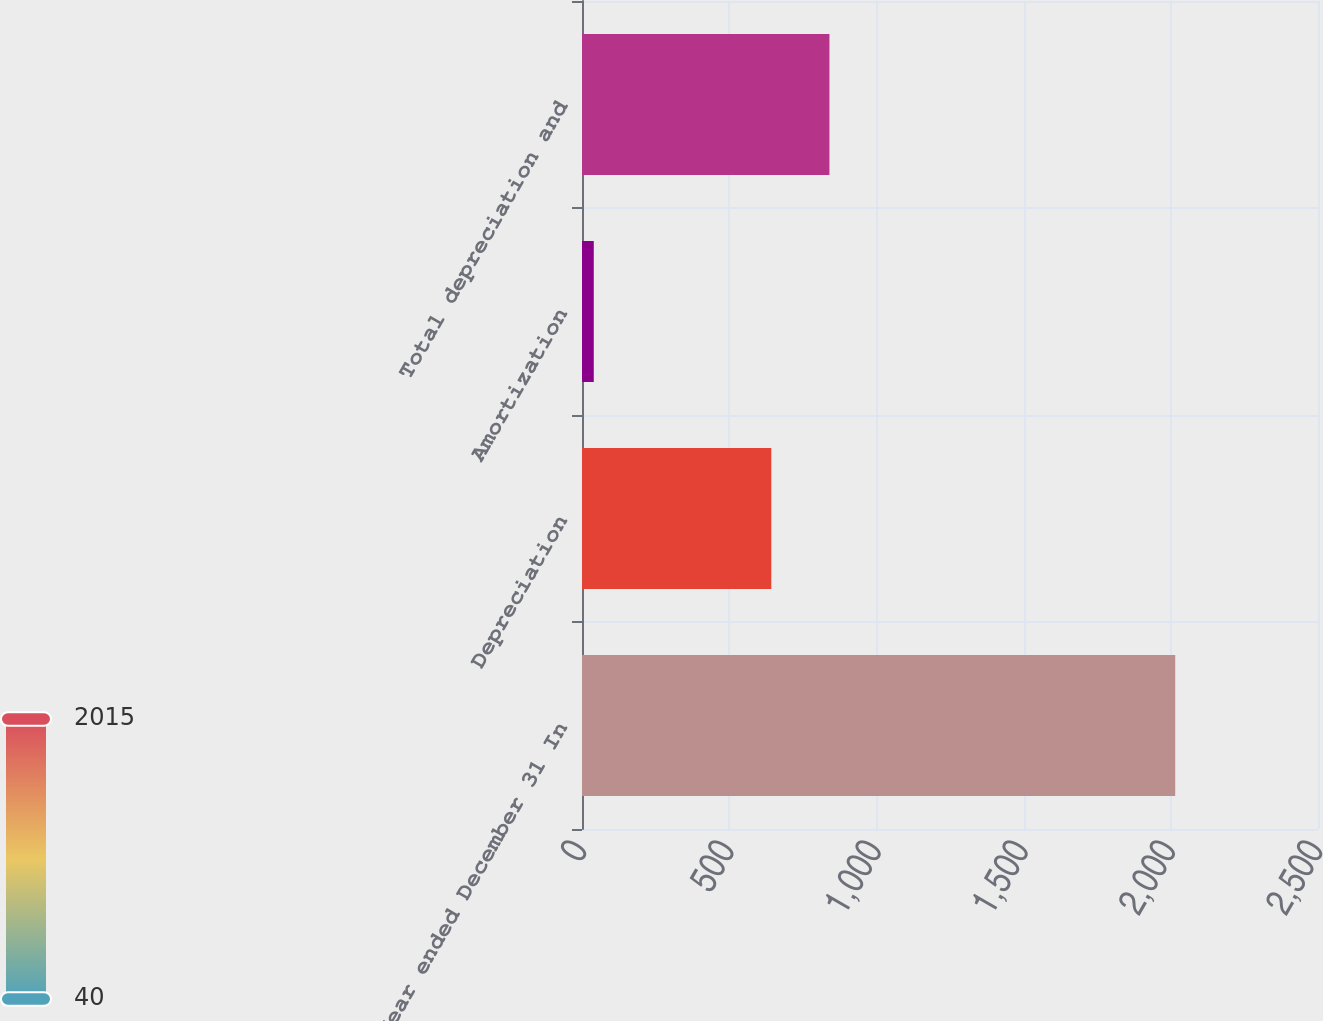<chart> <loc_0><loc_0><loc_500><loc_500><bar_chart><fcel>Year ended December 31 In<fcel>Depreciation<fcel>Amortization<fcel>Total depreciation and<nl><fcel>2015<fcel>643<fcel>40<fcel>840.5<nl></chart> 